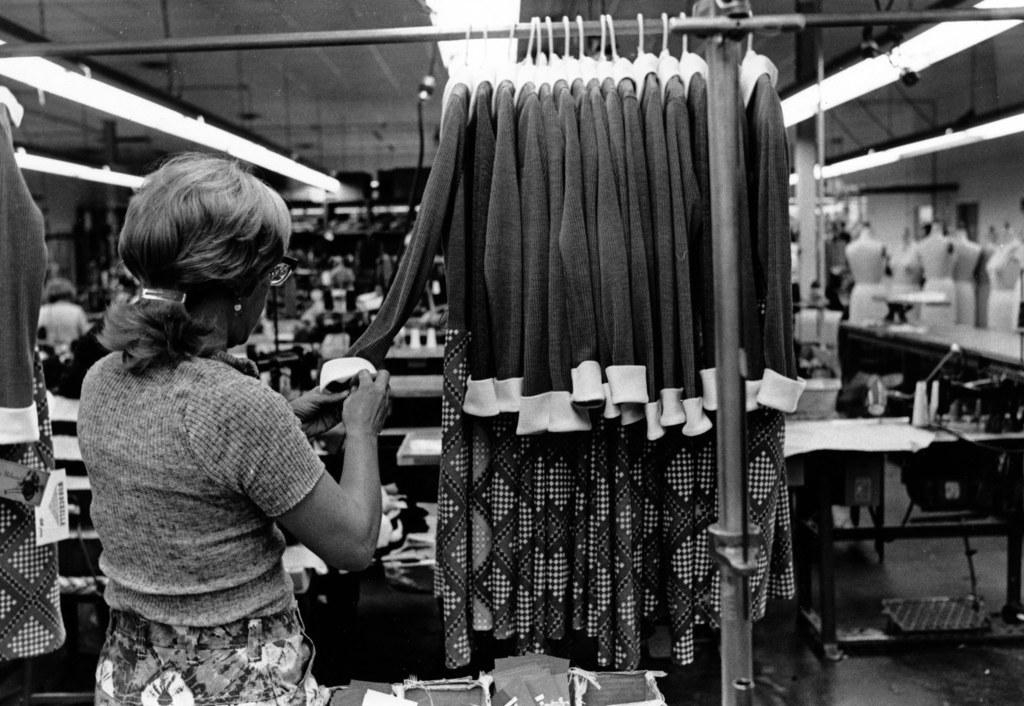Who is present in the image? There is a woman in the image. What is the woman holding in her hands? The woman is holding a cloth in her hands. What else can be seen in the image besides the woman? There are clothes on hangers, machines, and mannequins in the image. What type of bead is being used to help the chicken in the image? There is no bead or chicken present in the image. 